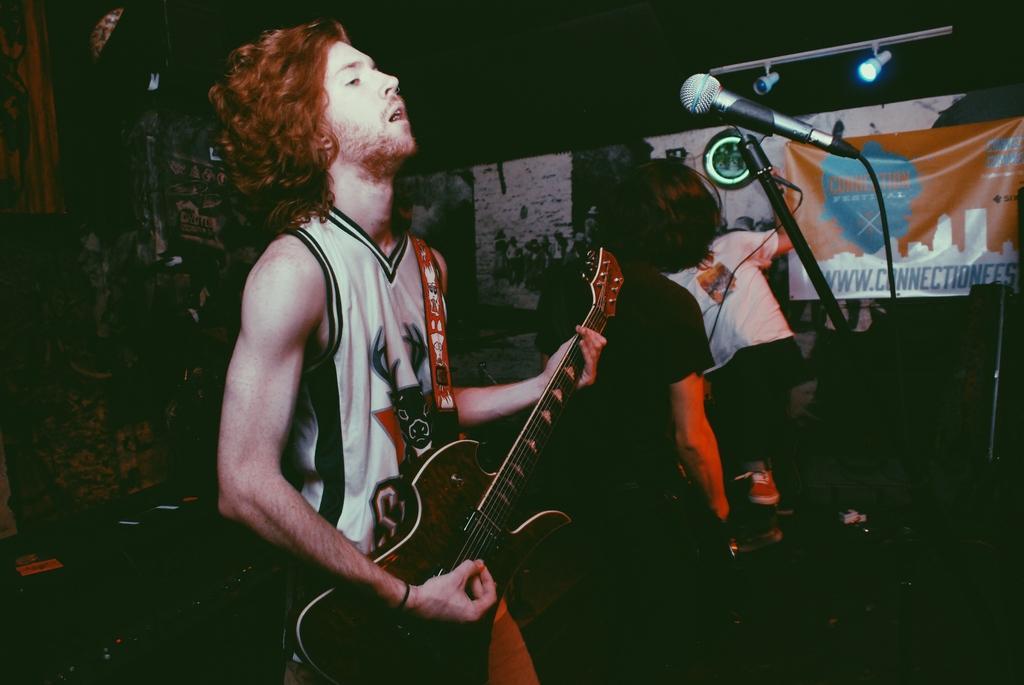How would you summarize this image in a sentence or two? In this picture we can see man holding guitar in his hand and playing and in front of him there is a mic and in the background we can see two persons, banner, light and here it is dark. 